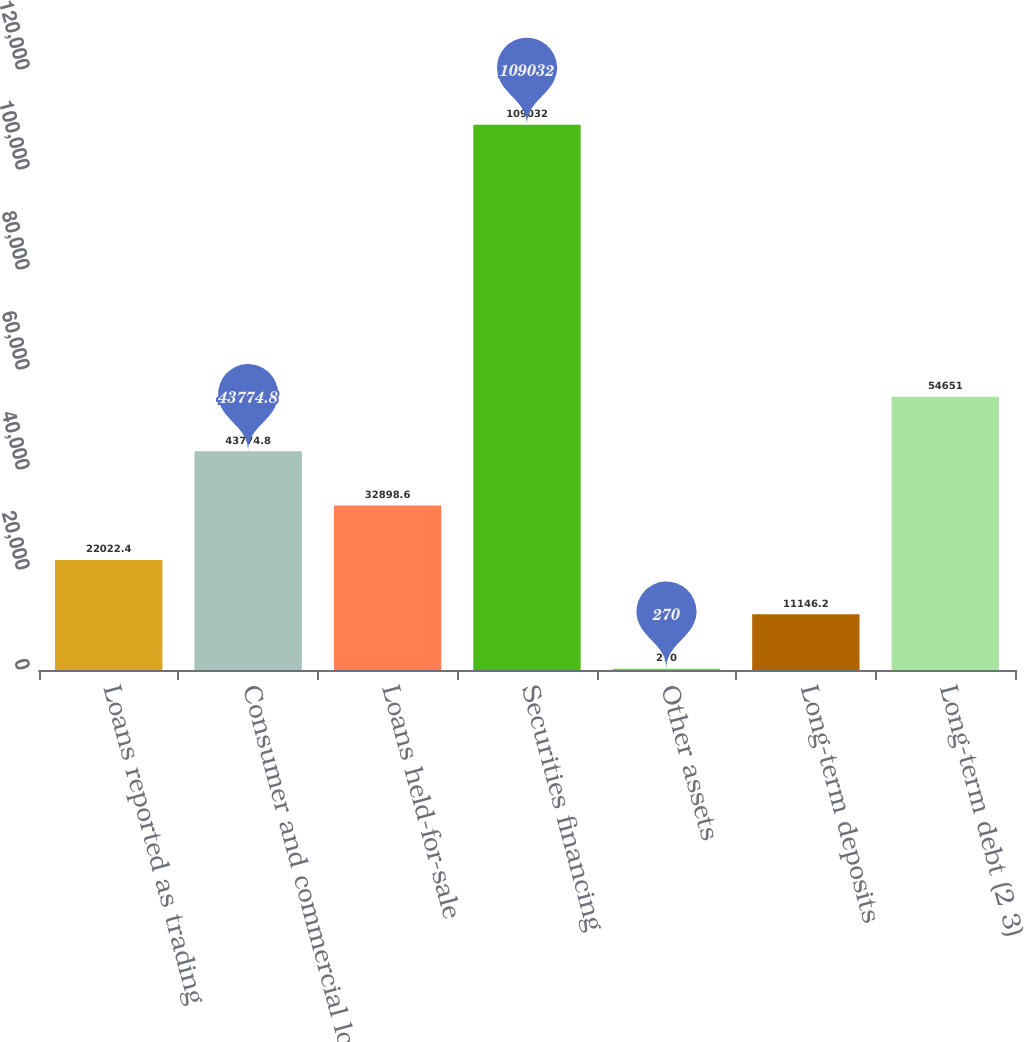Convert chart. <chart><loc_0><loc_0><loc_500><loc_500><bar_chart><fcel>Loans reported as trading<fcel>Consumer and commercial loans<fcel>Loans held-for-sale<fcel>Securities financing<fcel>Other assets<fcel>Long-term deposits<fcel>Long-term debt (2 3)<nl><fcel>22022.4<fcel>43774.8<fcel>32898.6<fcel>109032<fcel>270<fcel>11146.2<fcel>54651<nl></chart> 